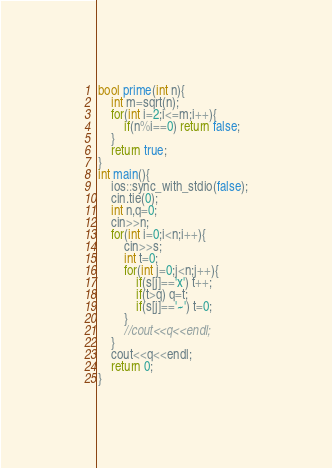Convert code to text. <code><loc_0><loc_0><loc_500><loc_500><_C++_>bool prime(int n){
	int m=sqrt(n);
	for(int i=2;i<=m;i++){
		if(n%i==0) return false;
	}
	return true;
}
int main(){
	ios::sync_with_stdio(false);
	cin.tie(0);
	int n,q=0;
	cin>>n;
	for(int i=0;i<n;i++){
		cin>>s;
		int t=0;
		for(int j=0;j<n;j++){
			if(s[j]=='x') t++;
			if(t>q) q=t;
			if(s[j]=='~') t=0;
		}
		//cout<<q<<endl;
	}
	cout<<q<<endl;
	return 0;
}

</code> 